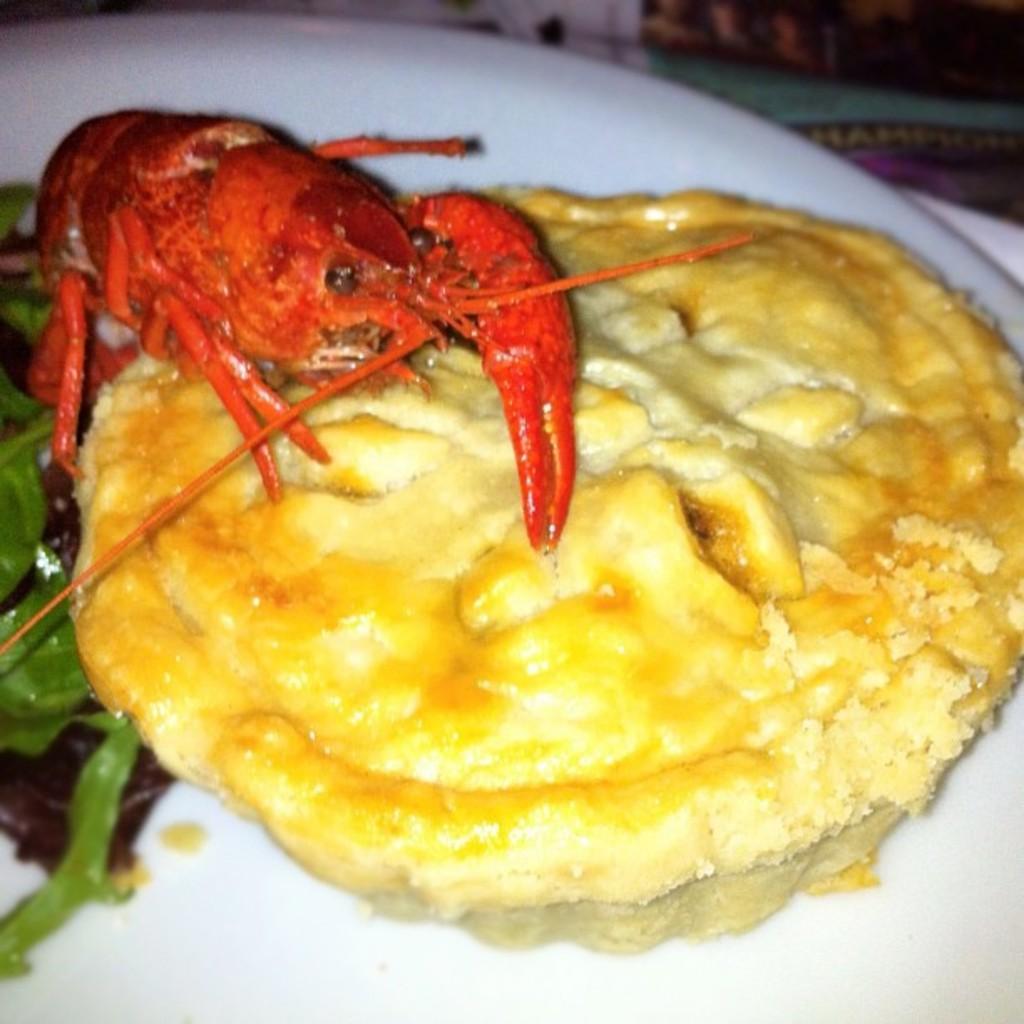Can you describe this image briefly? In this image I can see a plate which consists of some food and a crab. 